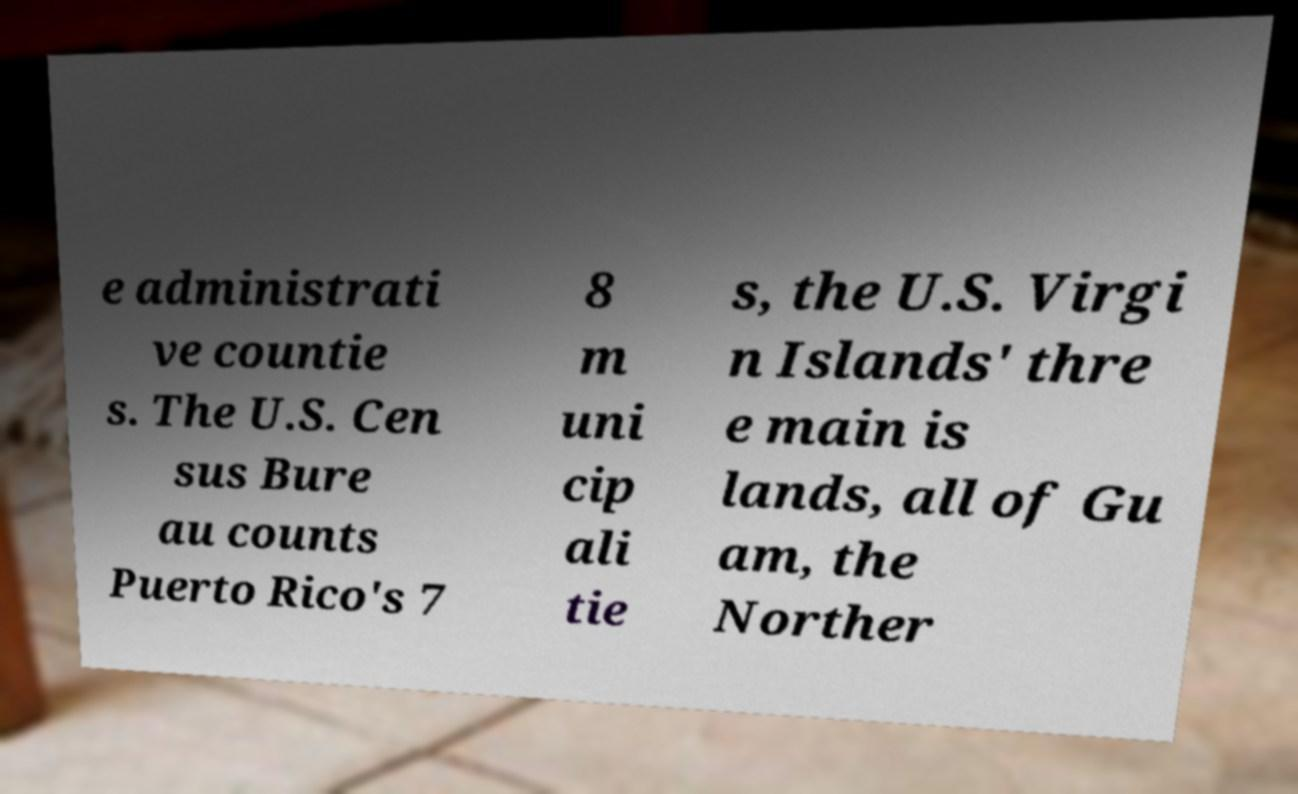Could you assist in decoding the text presented in this image and type it out clearly? e administrati ve countie s. The U.S. Cen sus Bure au counts Puerto Rico's 7 8 m uni cip ali tie s, the U.S. Virgi n Islands' thre e main is lands, all of Gu am, the Norther 